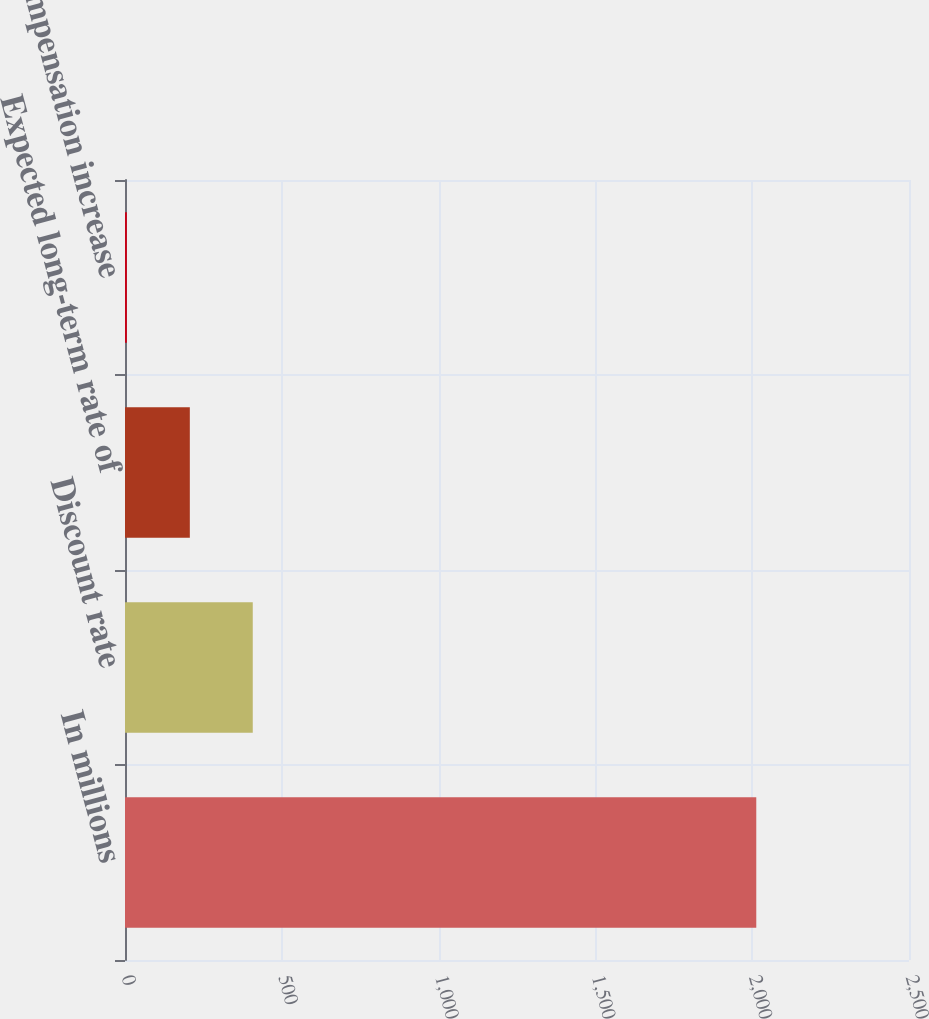Convert chart. <chart><loc_0><loc_0><loc_500><loc_500><bar_chart><fcel>In millions<fcel>Discount rate<fcel>Expected long-term rate of<fcel>Rate of compensation increase<nl><fcel>2013<fcel>407.4<fcel>206.7<fcel>6<nl></chart> 